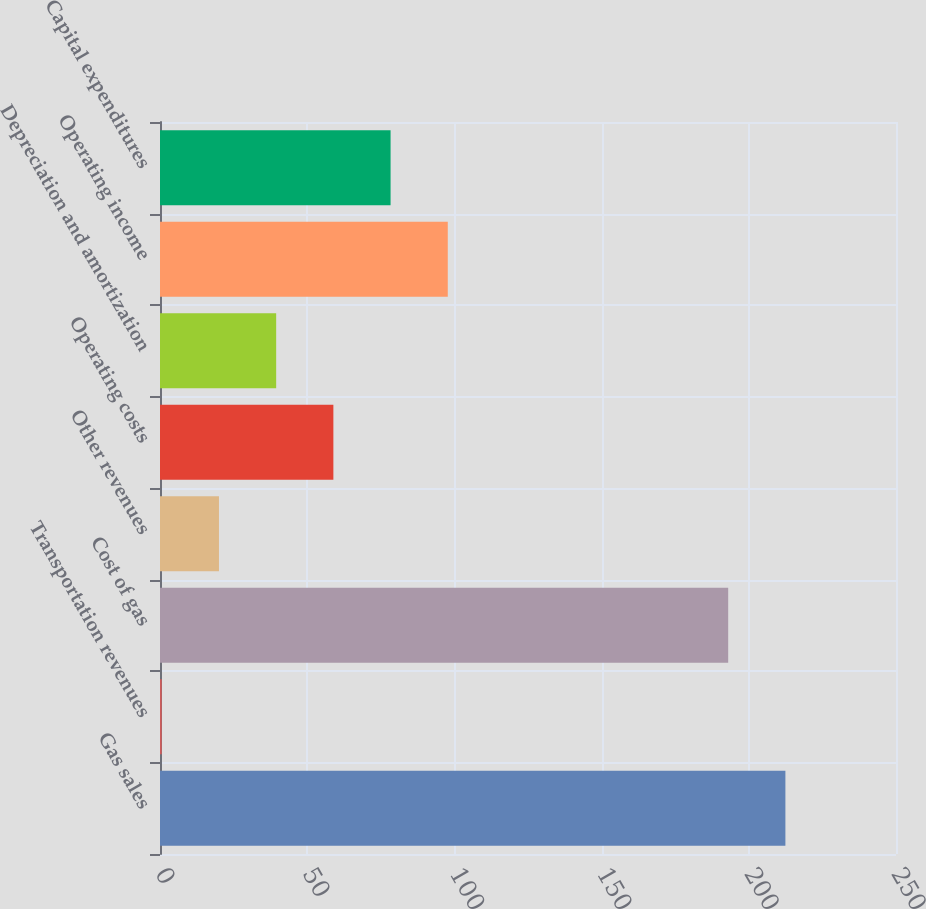Convert chart. <chart><loc_0><loc_0><loc_500><loc_500><bar_chart><fcel>Gas sales<fcel>Transportation revenues<fcel>Cost of gas<fcel>Other revenues<fcel>Operating costs<fcel>Depreciation and amortization<fcel>Operating income<fcel>Capital expenditures<nl><fcel>212.43<fcel>0.6<fcel>193<fcel>20.03<fcel>58.89<fcel>39.46<fcel>97.75<fcel>78.32<nl></chart> 